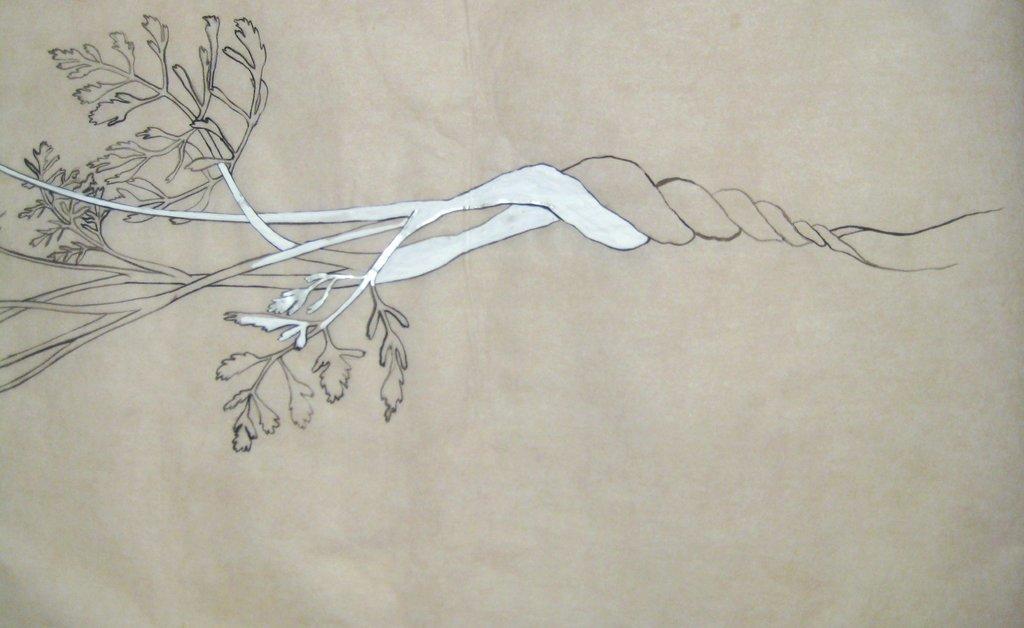Please provide a concise description of this image. In this image I can see a painting of a tree. 